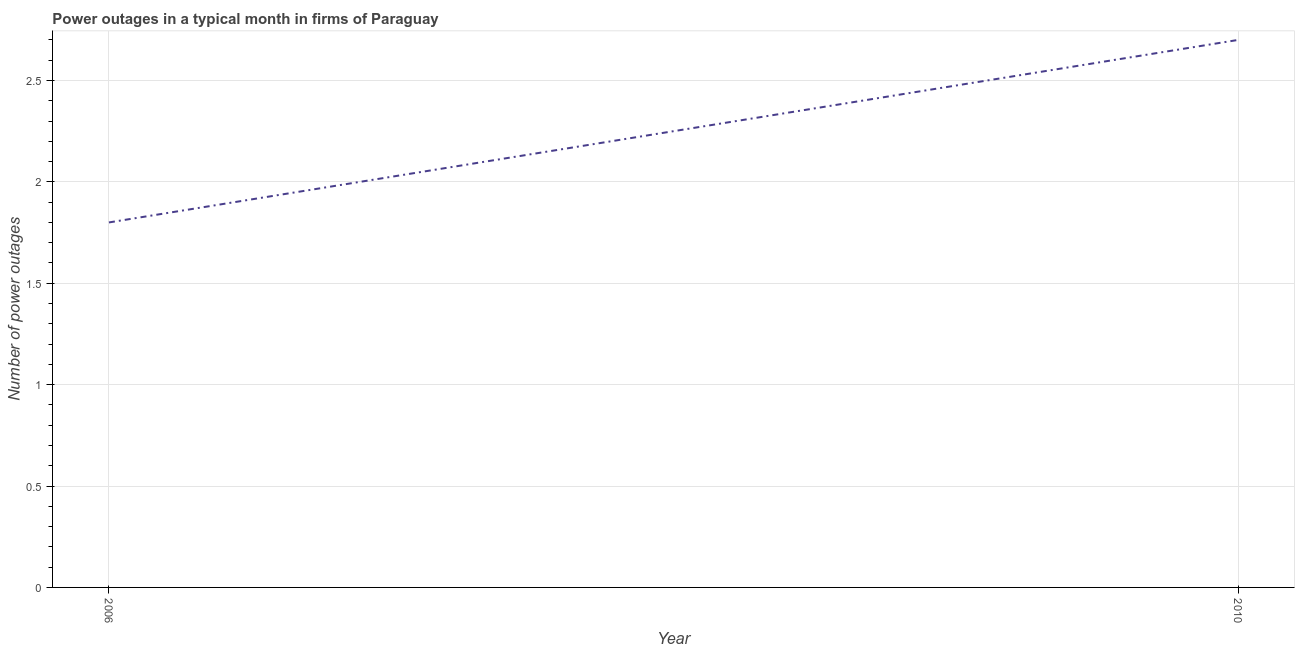In which year was the number of power outages maximum?
Give a very brief answer. 2010. In which year was the number of power outages minimum?
Give a very brief answer. 2006. What is the difference between the number of power outages in 2006 and 2010?
Ensure brevity in your answer.  -0.9. What is the average number of power outages per year?
Ensure brevity in your answer.  2.25. What is the median number of power outages?
Your response must be concise. 2.25. What is the ratio of the number of power outages in 2006 to that in 2010?
Make the answer very short. 0.67. Does the number of power outages monotonically increase over the years?
Ensure brevity in your answer.  Yes. Does the graph contain any zero values?
Your answer should be very brief. No. What is the title of the graph?
Your answer should be compact. Power outages in a typical month in firms of Paraguay. What is the label or title of the Y-axis?
Make the answer very short. Number of power outages. What is the ratio of the Number of power outages in 2006 to that in 2010?
Make the answer very short. 0.67. 